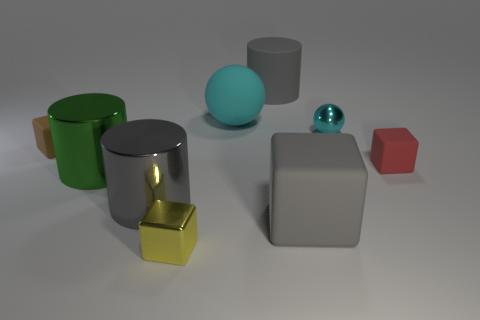Subtract all small yellow cubes. How many cubes are left? 3 Add 1 cubes. How many objects exist? 10 Subtract all gray cubes. How many green cylinders are left? 1 Subtract all gray cylinders. How many cylinders are left? 1 Subtract 2 spheres. How many spheres are left? 0 Add 4 gray matte cylinders. How many gray matte cylinders are left? 5 Add 5 big green things. How many big green things exist? 6 Subtract 0 cyan cylinders. How many objects are left? 9 Subtract all cubes. How many objects are left? 5 Subtract all yellow balls. Subtract all yellow blocks. How many balls are left? 2 